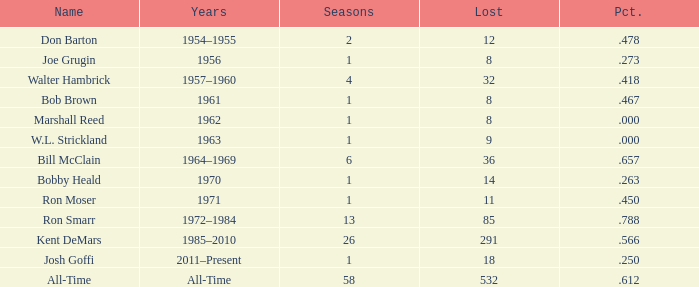During which seasons is joe grugin named and has a lost greater than 8? 0.0. 